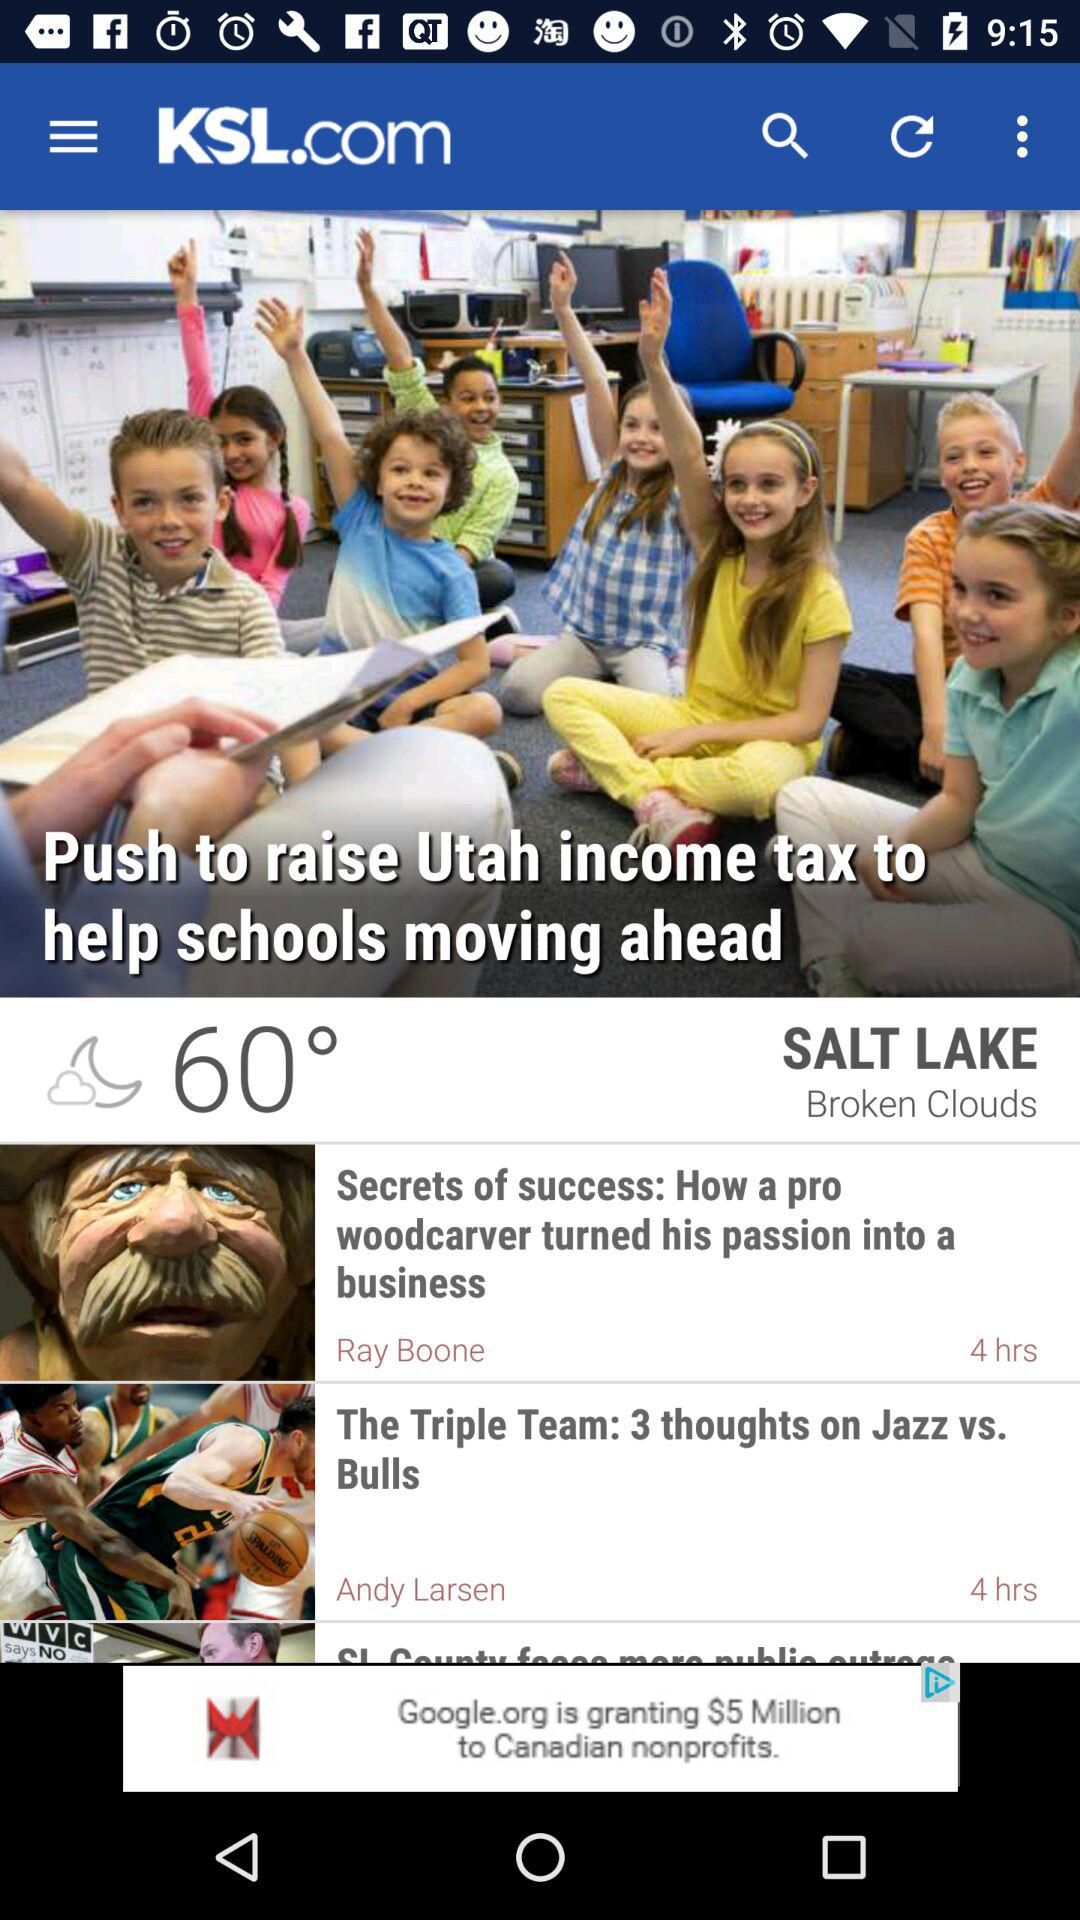How many hours ago was the most recent story published?
Answer the question using a single word or phrase. 4 